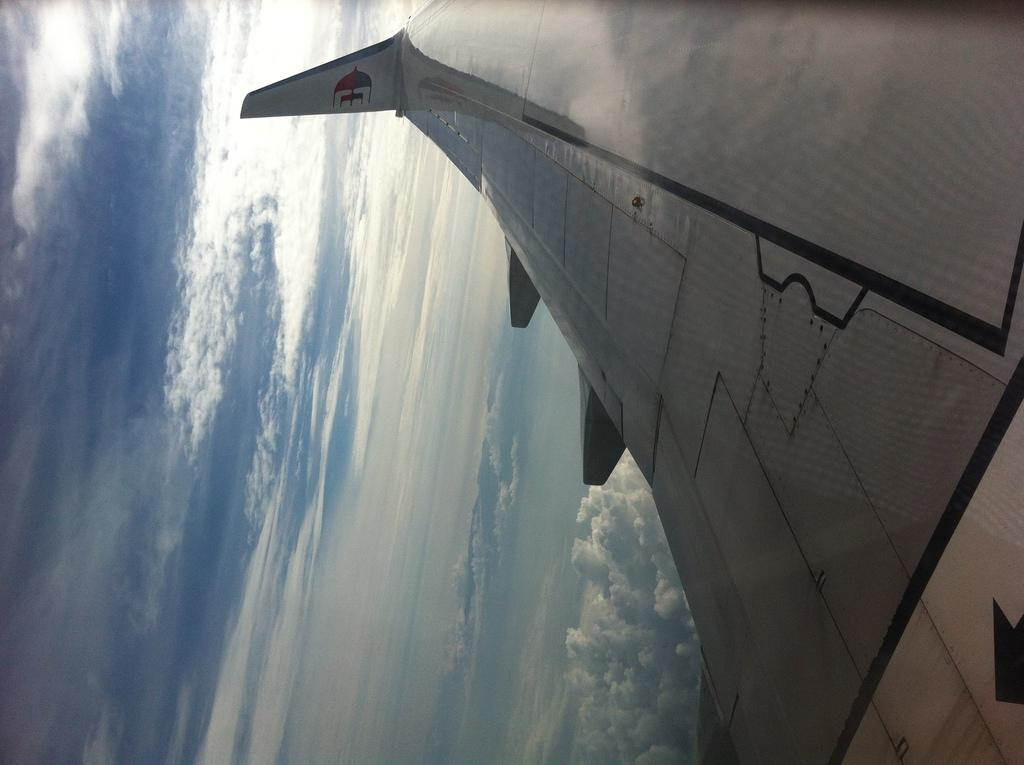What is the main subject of the image? The main subject of the image is an aircraft. What specific part of the aircraft can be seen in the image? The rudder of the aircraft is visible. What is the condition of the sky in the image? The sky is cloudy in the image. How many oranges are hanging from the rudder of the aircraft in the image? There are no oranges present in the image, and therefore no such activity can be observed. Is the aircraft in the image taking a nap or sleeping? Aircrafts do not have the ability to nap or sleep, so this question is not applicable to the image. 